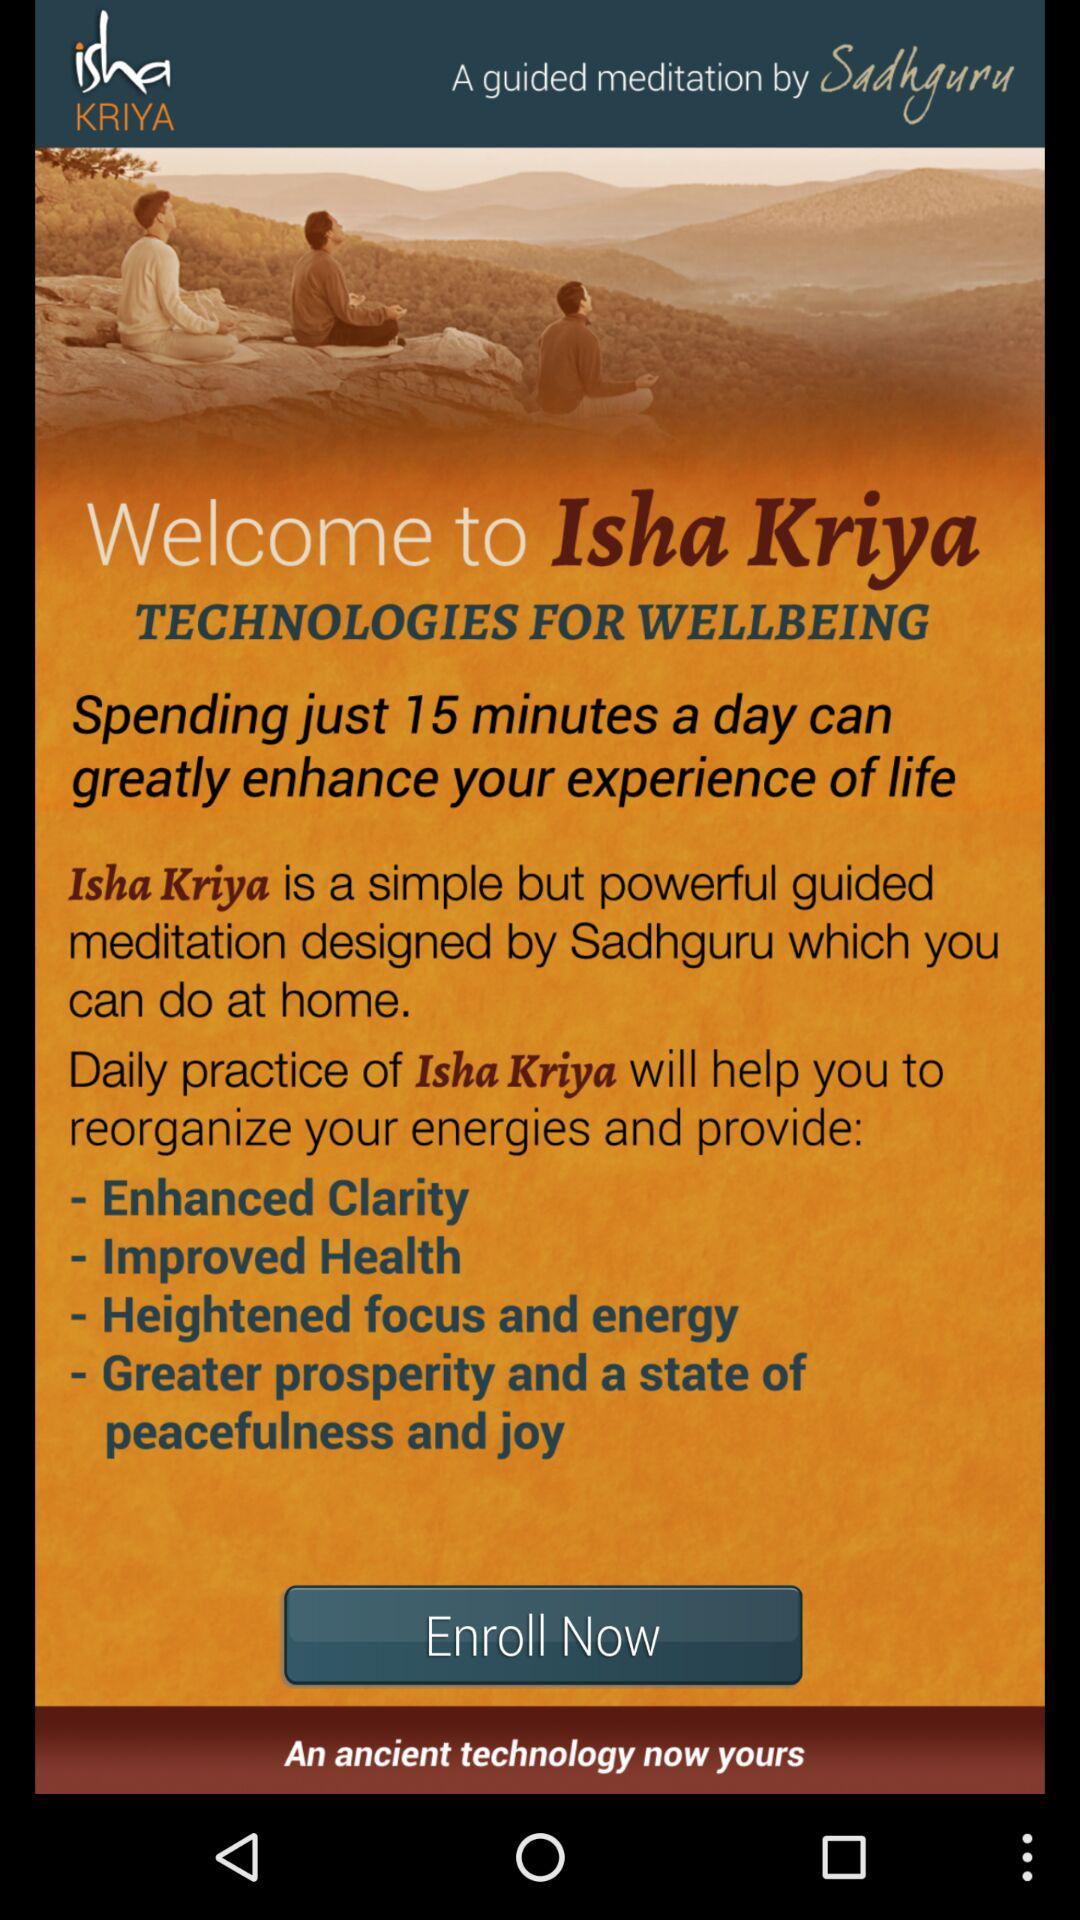What exactly is Isha Kriya? Isha Kriya is a simple but powerful guided meditation. 